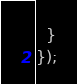<code> <loc_0><loc_0><loc_500><loc_500><_JavaScript_>  }
});
</code> 